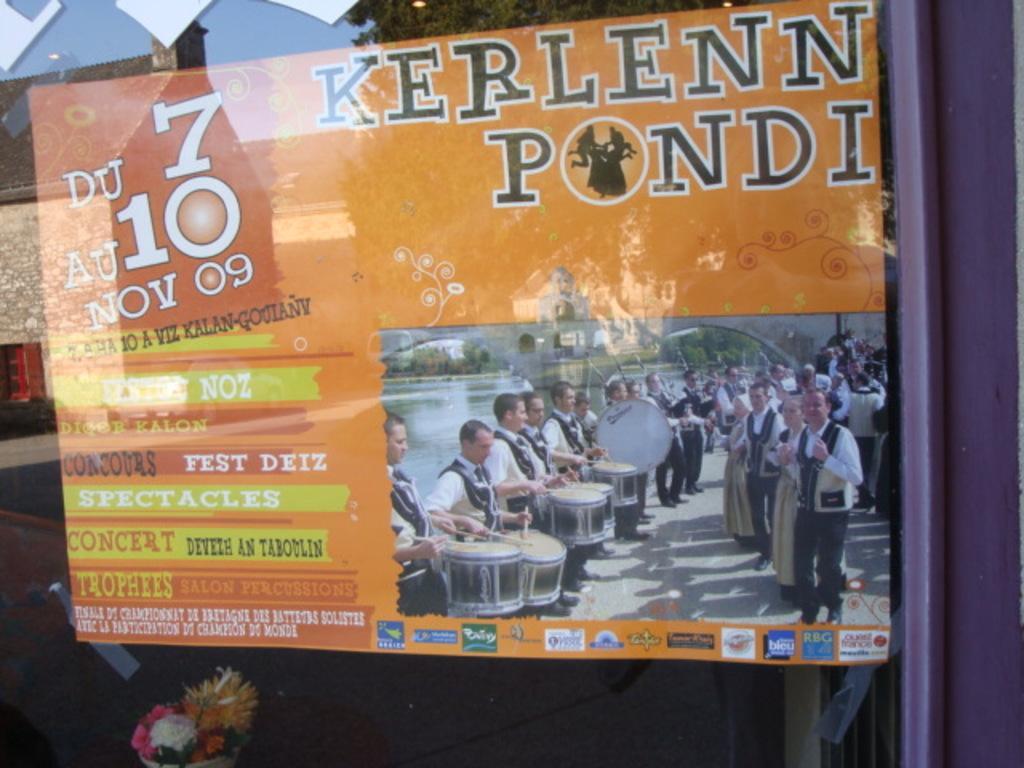Describe this image in one or two sentences. In this image we can see the glass wall and there is a poster with some text and on the poster, we can see a few people are playing musical instruments and few people looks like they are dancing and we can see the water. We can see the reflection of two buildings and a tree on the glass wall and there is a flower bouquet at the bottom of the image. 